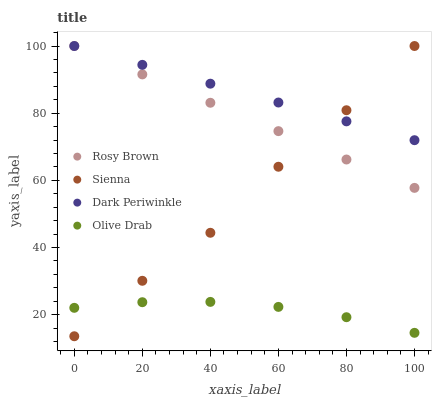Does Olive Drab have the minimum area under the curve?
Answer yes or no. Yes. Does Dark Periwinkle have the maximum area under the curve?
Answer yes or no. Yes. Does Rosy Brown have the minimum area under the curve?
Answer yes or no. No. Does Rosy Brown have the maximum area under the curve?
Answer yes or no. No. Is Rosy Brown the smoothest?
Answer yes or no. Yes. Is Sienna the roughest?
Answer yes or no. Yes. Is Olive Drab the smoothest?
Answer yes or no. No. Is Olive Drab the roughest?
Answer yes or no. No. Does Sienna have the lowest value?
Answer yes or no. Yes. Does Rosy Brown have the lowest value?
Answer yes or no. No. Does Dark Periwinkle have the highest value?
Answer yes or no. Yes. Does Olive Drab have the highest value?
Answer yes or no. No. Is Olive Drab less than Dark Periwinkle?
Answer yes or no. Yes. Is Rosy Brown greater than Olive Drab?
Answer yes or no. Yes. Does Sienna intersect Olive Drab?
Answer yes or no. Yes. Is Sienna less than Olive Drab?
Answer yes or no. No. Is Sienna greater than Olive Drab?
Answer yes or no. No. Does Olive Drab intersect Dark Periwinkle?
Answer yes or no. No. 